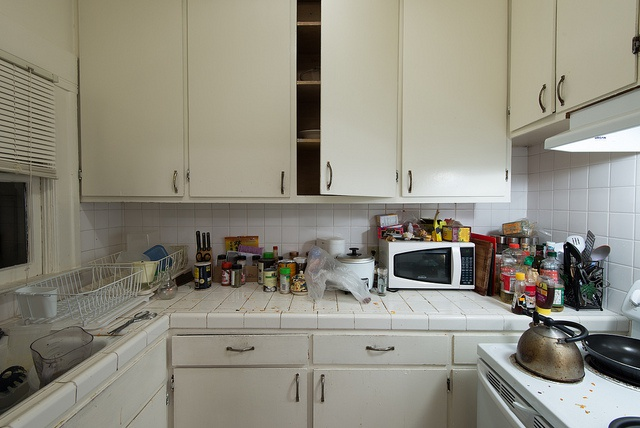Describe the objects in this image and their specific colors. I can see oven in darkgray, lightgray, gray, and black tones, sink in darkgray, gray, and black tones, microwave in darkgray, black, lightgray, and gray tones, bottle in darkgray, gray, and brown tones, and bottle in darkgray, gray, black, and lightgray tones in this image. 